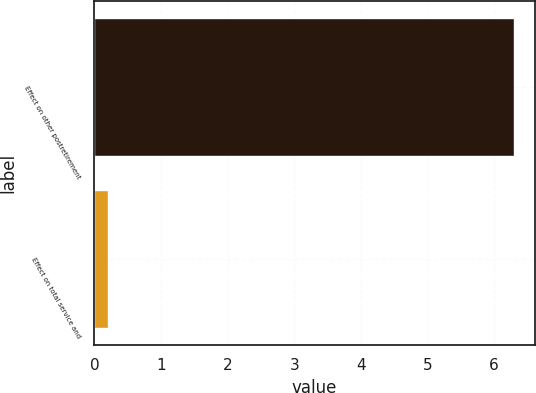Convert chart. <chart><loc_0><loc_0><loc_500><loc_500><bar_chart><fcel>Effect on other postretirement<fcel>Effect on total service and<nl><fcel>6.3<fcel>0.2<nl></chart> 